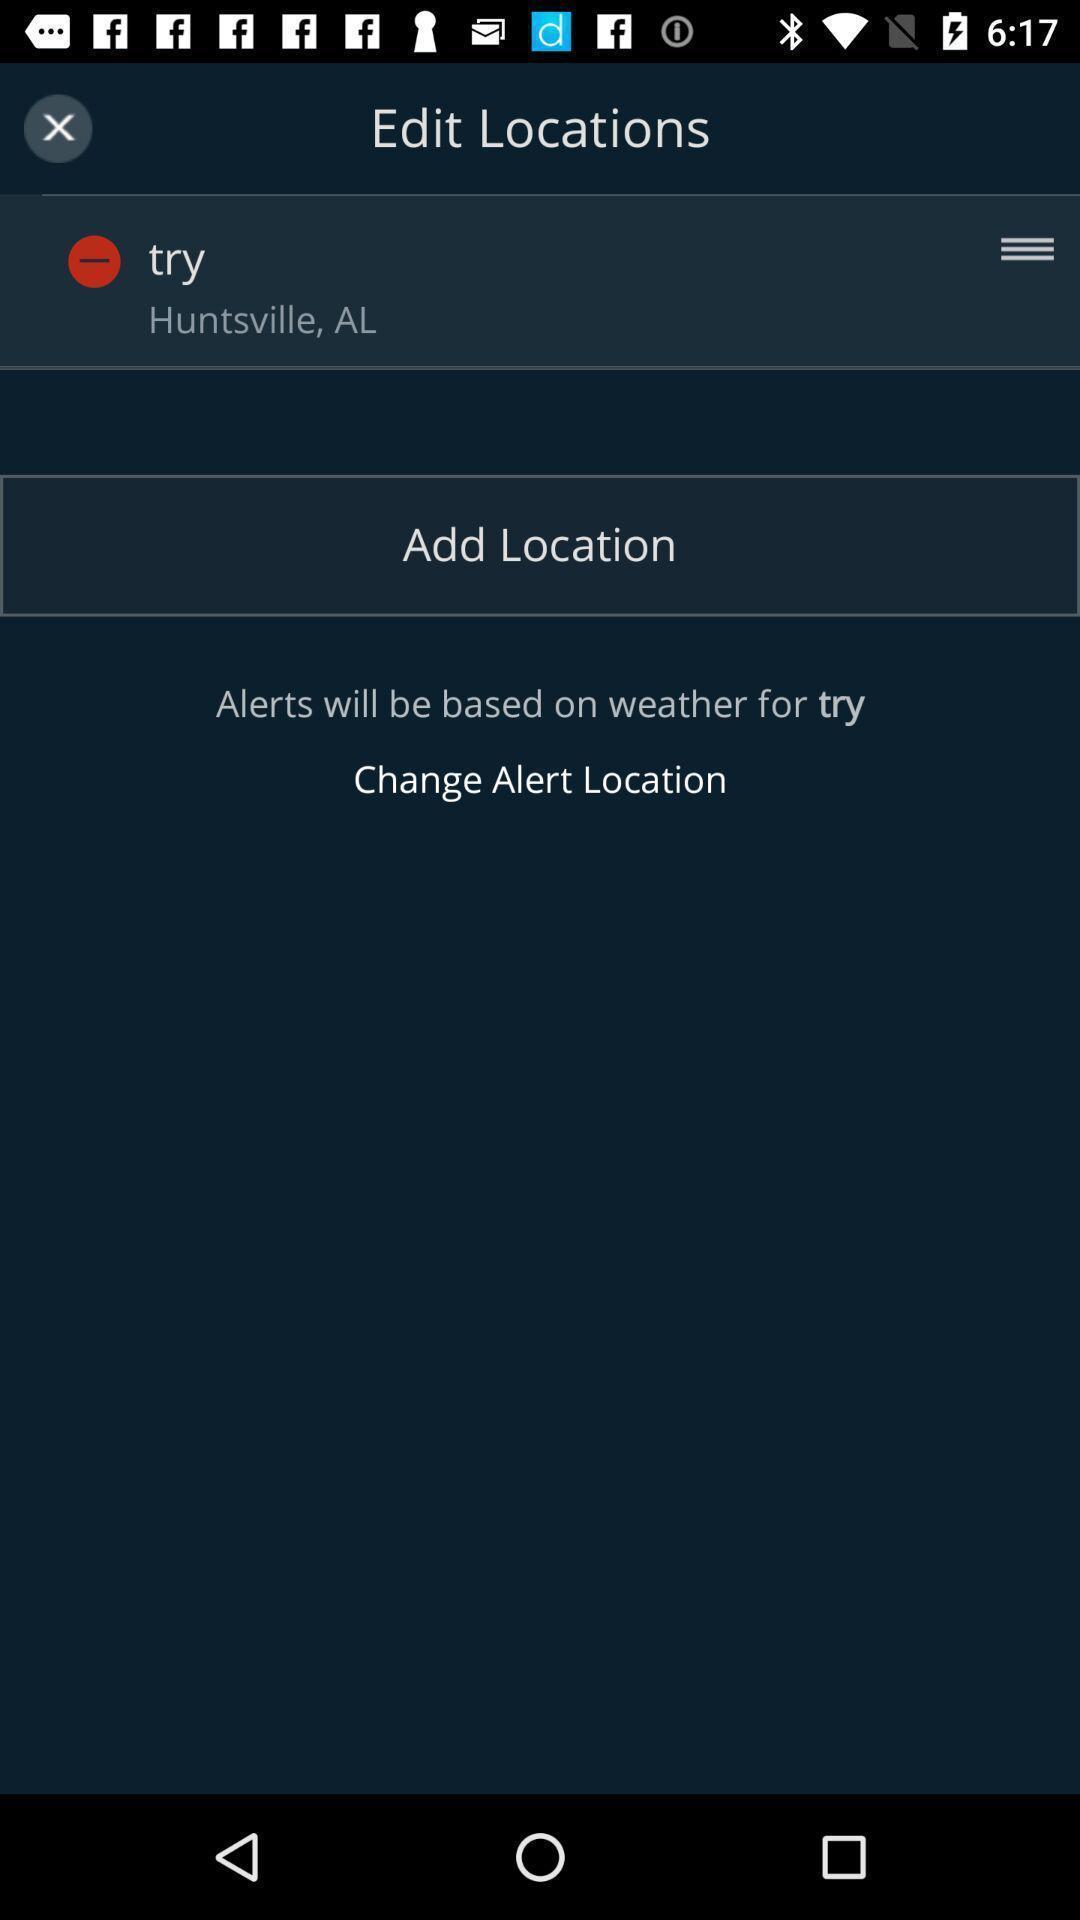Please provide a description for this image. Page showing a particular location with add location button. 